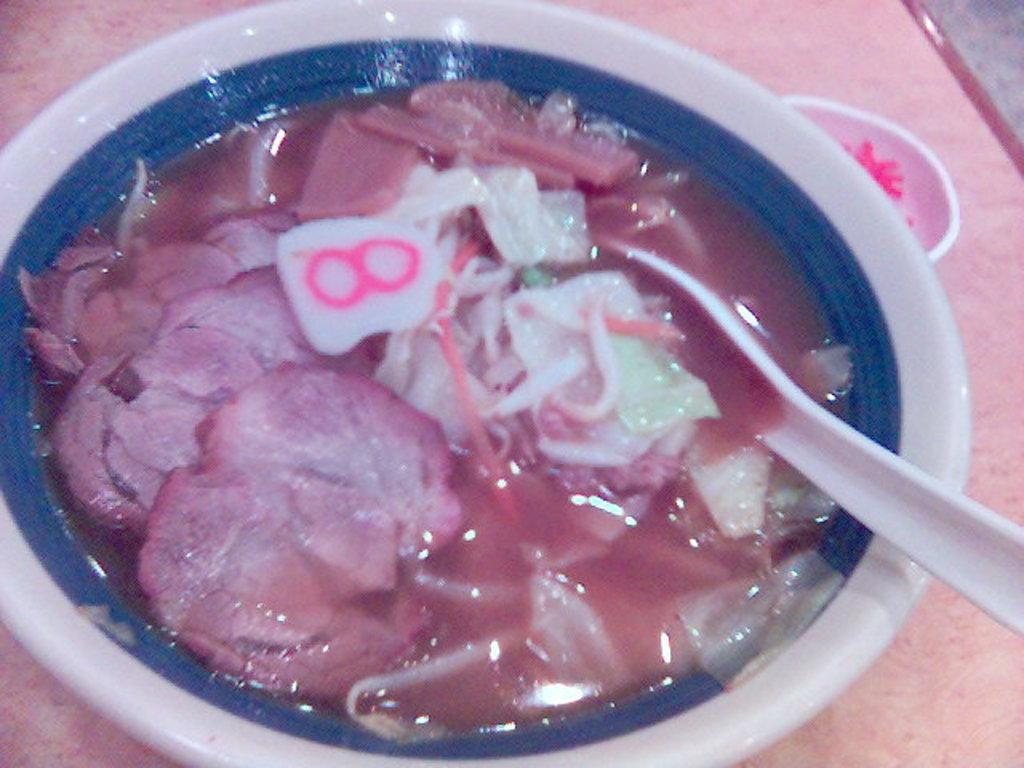Please provide a concise description of this image. In this image I can see food in the bowl. The bowl is in white color, I can also see a spoon in the bowl which is in white color. 